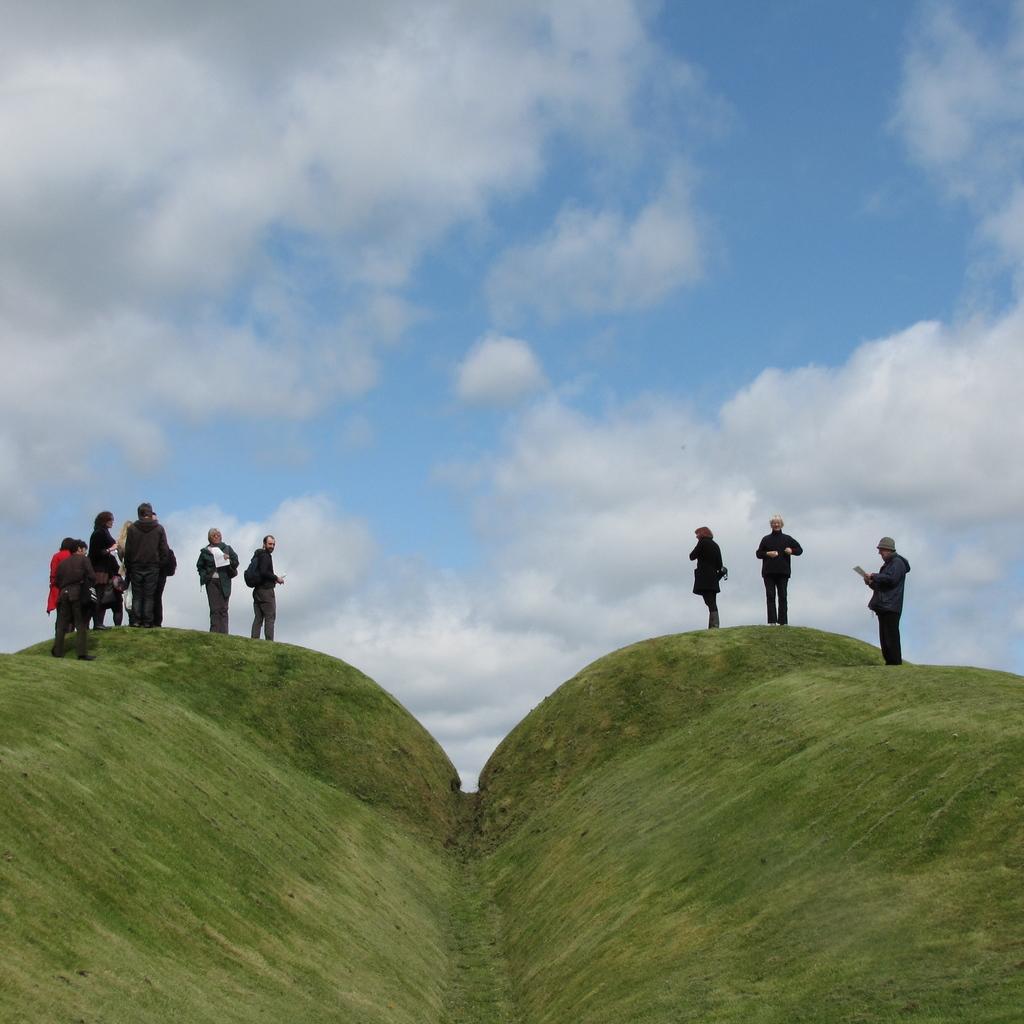Could you give a brief overview of what you see in this image? There are people standing on the green cliffs in the foreground area of the image and the sky in the background. 